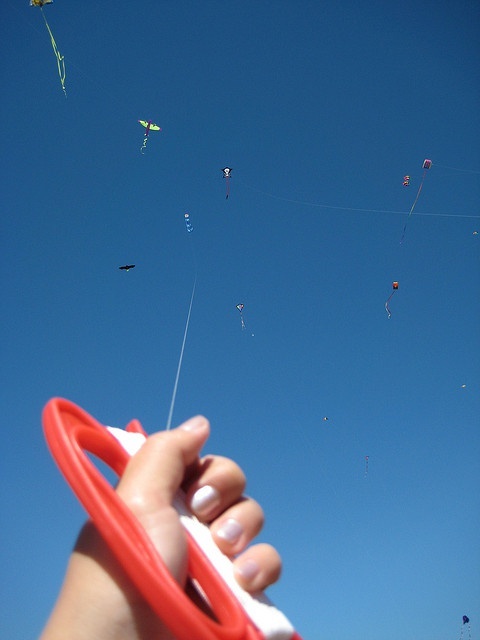Describe the objects in this image and their specific colors. I can see people in darkblue, tan, lightgray, and maroon tones, kite in darkblue, blue, gray, and navy tones, kite in darkblue, blue, navy, and black tones, kite in darkblue, blue, black, and navy tones, and kite in darkblue, gray, and darkgray tones in this image. 